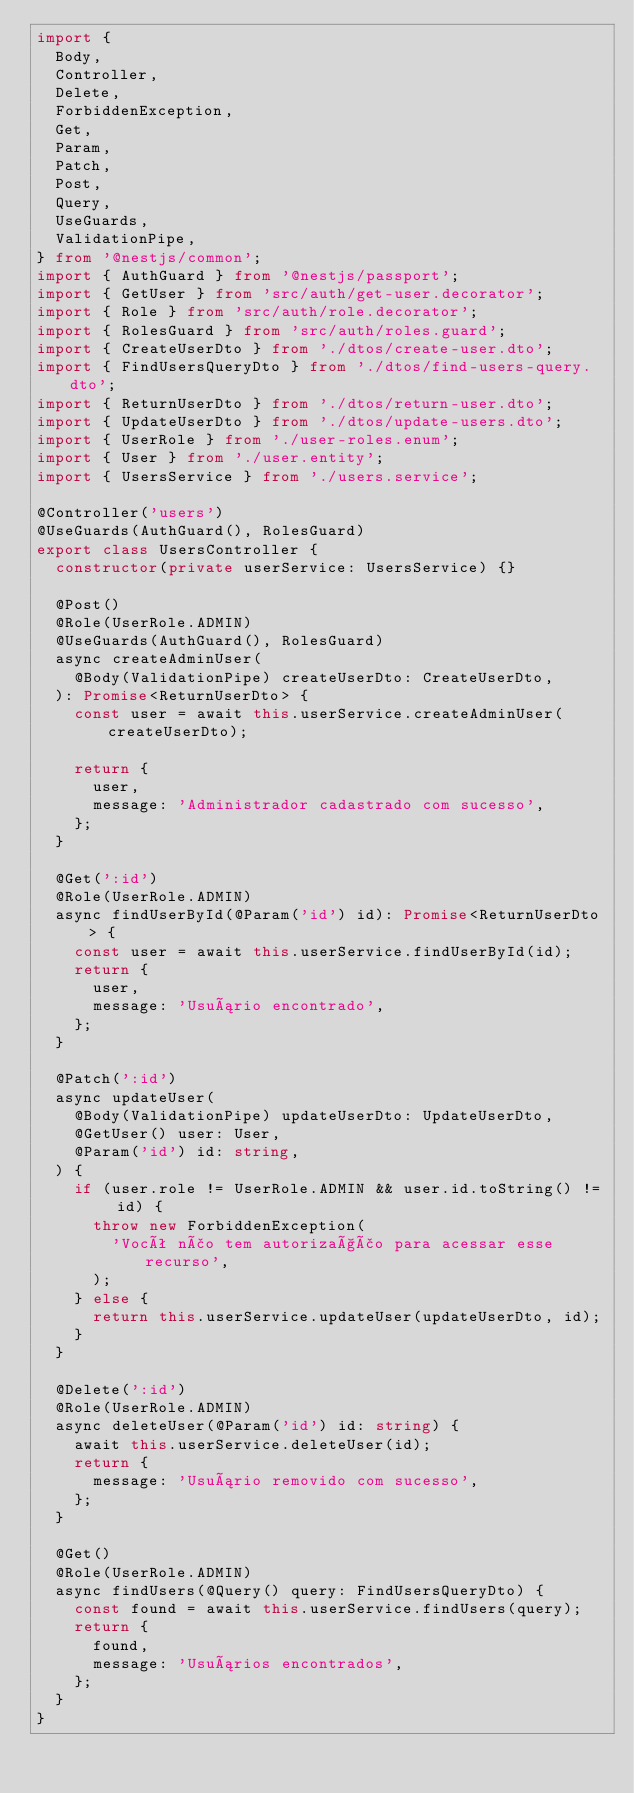<code> <loc_0><loc_0><loc_500><loc_500><_TypeScript_>import {
  Body,
  Controller,
  Delete,
  ForbiddenException,
  Get,
  Param,
  Patch,
  Post,
  Query,
  UseGuards,
  ValidationPipe,
} from '@nestjs/common';
import { AuthGuard } from '@nestjs/passport';
import { GetUser } from 'src/auth/get-user.decorator';
import { Role } from 'src/auth/role.decorator';
import { RolesGuard } from 'src/auth/roles.guard';
import { CreateUserDto } from './dtos/create-user.dto';
import { FindUsersQueryDto } from './dtos/find-users-query.dto';
import { ReturnUserDto } from './dtos/return-user.dto';
import { UpdateUserDto } from './dtos/update-users.dto';
import { UserRole } from './user-roles.enum';
import { User } from './user.entity';
import { UsersService } from './users.service';

@Controller('users')
@UseGuards(AuthGuard(), RolesGuard)
export class UsersController {
  constructor(private userService: UsersService) {}

  @Post()
  @Role(UserRole.ADMIN)
  @UseGuards(AuthGuard(), RolesGuard)
  async createAdminUser(
    @Body(ValidationPipe) createUserDto: CreateUserDto,
  ): Promise<ReturnUserDto> {
    const user = await this.userService.createAdminUser(createUserDto);

    return {
      user,
      message: 'Administrador cadastrado com sucesso',
    };
  }

  @Get(':id')
  @Role(UserRole.ADMIN)
  async findUserById(@Param('id') id): Promise<ReturnUserDto> {
    const user = await this.userService.findUserById(id);
    return {
      user,
      message: 'Usuário encontrado',
    };
  }

  @Patch(':id')
  async updateUser(
    @Body(ValidationPipe) updateUserDto: UpdateUserDto,
    @GetUser() user: User,
    @Param('id') id: string,
  ) {
    if (user.role != UserRole.ADMIN && user.id.toString() != id) {
      throw new ForbiddenException(
        'Você não tem autorização para acessar esse recurso',
      );
    } else {
      return this.userService.updateUser(updateUserDto, id);
    }
  }

  @Delete(':id')
  @Role(UserRole.ADMIN)
  async deleteUser(@Param('id') id: string) {
    await this.userService.deleteUser(id);
    return {
      message: 'Usuário removido com sucesso',
    };
  }

  @Get()
  @Role(UserRole.ADMIN)
  async findUsers(@Query() query: FindUsersQueryDto) {
    const found = await this.userService.findUsers(query);
    return {
      found,
      message: 'Usuários encontrados',
    };
  }
}
</code> 